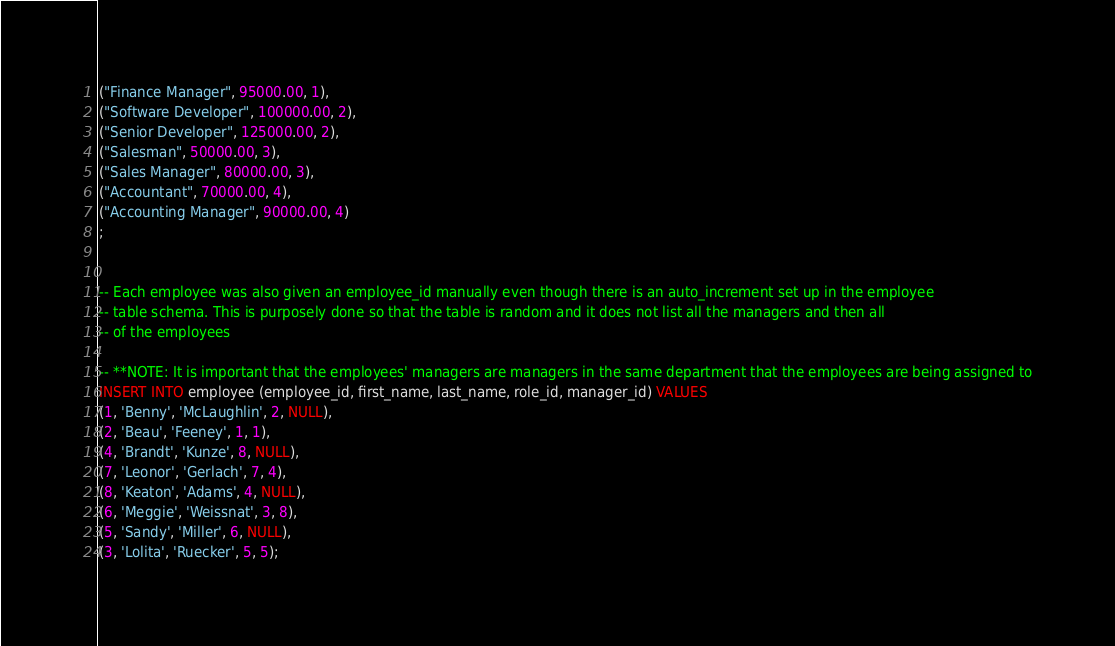<code> <loc_0><loc_0><loc_500><loc_500><_SQL_>("Finance Manager", 95000.00, 1),
("Software Developer", 100000.00, 2),
("Senior Developer", 125000.00, 2),
("Salesman", 50000.00, 3),
("Sales Manager", 80000.00, 3),
("Accountant", 70000.00, 4),
("Accounting Manager", 90000.00, 4)
;


-- Each employee was also given an employee_id manually even though there is an auto_increment set up in the employee
-- table schema. This is purposely done so that the table is random and it does not list all the managers and then all
-- of the employees

-- **NOTE: It is important that the employees' managers are managers in the same department that the employees are being assigned to
INSERT INTO employee (employee_id, first_name, last_name, role_id, manager_id) VALUES 
(1, 'Benny', 'McLaughlin', 2, NULL),
(2, 'Beau', 'Feeney', 1, 1),
(4, 'Brandt', 'Kunze', 8, NULL),
(7, 'Leonor', 'Gerlach', 7, 4),
(8, 'Keaton', 'Adams', 4, NULL),
(6, 'Meggie', 'Weissnat', 3, 8),
(5, 'Sandy', 'Miller', 6, NULL),
(3, 'Lolita', 'Ruecker', 5, 5);</code> 